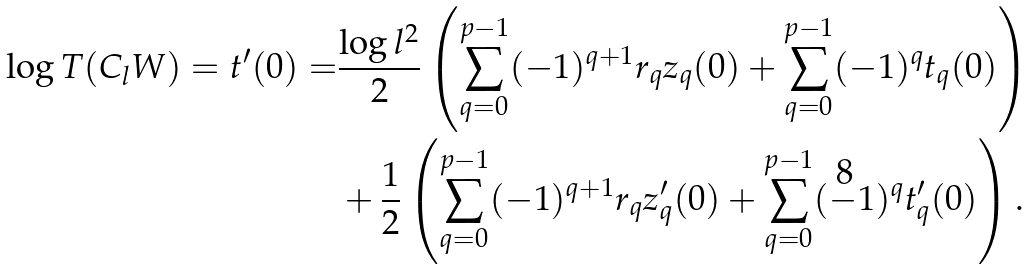Convert formula to latex. <formula><loc_0><loc_0><loc_500><loc_500>\log T ( C _ { l } W ) = t ^ { \prime } ( 0 ) = & \frac { \log l ^ { 2 } } { 2 } \left ( \sum _ { q = 0 } ^ { p - 1 } ( - 1 ) ^ { q + 1 } r _ { q } z _ { q } ( 0 ) + \sum ^ { p - 1 } _ { q = 0 } ( - 1 ) ^ { q } t _ { q } ( 0 ) \right ) \\ & + \frac { 1 } { 2 } \left ( \sum _ { q = 0 } ^ { p - 1 } ( - 1 ) ^ { q + 1 } r _ { q } z _ { q } ^ { \prime } ( 0 ) + \sum ^ { p - 1 } _ { q = 0 } ( - 1 ) ^ { q } t _ { q } ^ { \prime } ( 0 ) \right ) .</formula> 